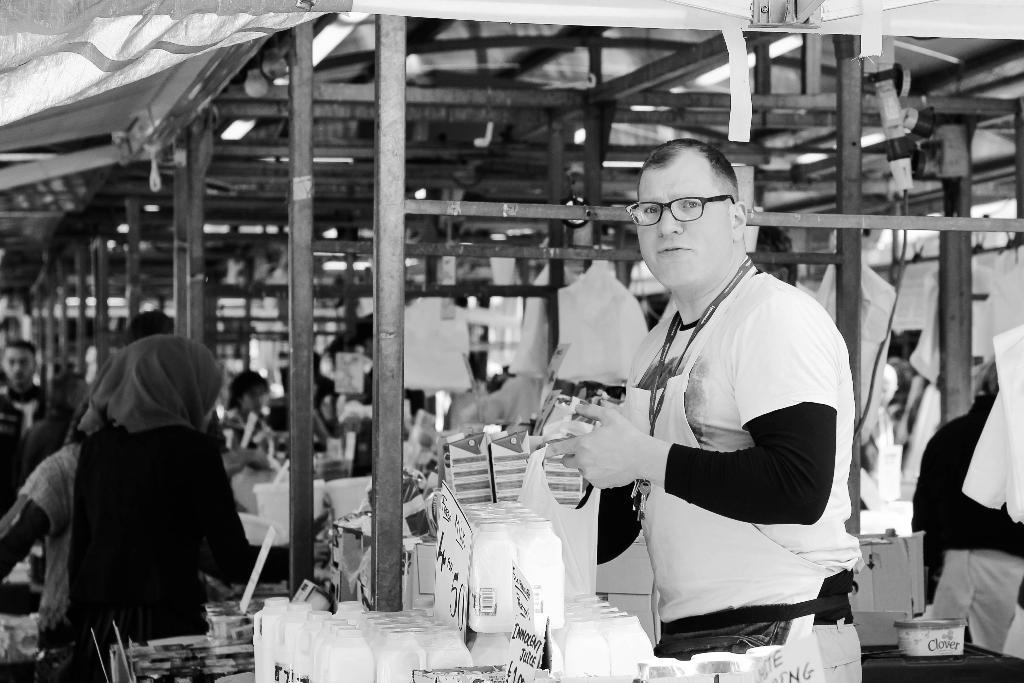Describe this image in one or two sentences. This is a black and white image. On the right side there is a man standing, holding an object in the hands and looking at the picture. At the bottom there are few bottle. On the right side there is a table on which few objects are placed. In the background there are many metal stands and many objects are placed on the ground. On the right side few people are standing. At the top of the image there is a cloth. 